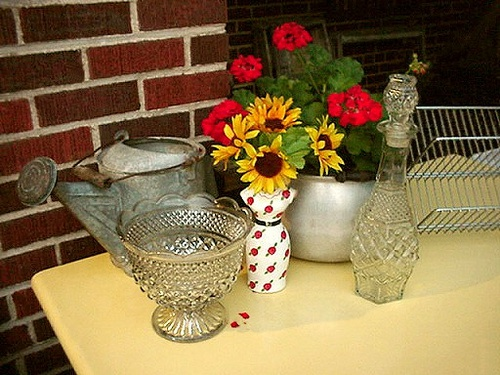Describe the objects in this image and their specific colors. I can see dining table in gray, khaki, tan, black, and olive tones, potted plant in gray, black, darkgreen, and brown tones, bowl in gray, tan, and olive tones, potted plant in gray, beige, orange, black, and maroon tones, and bottle in gray, tan, and olive tones in this image. 